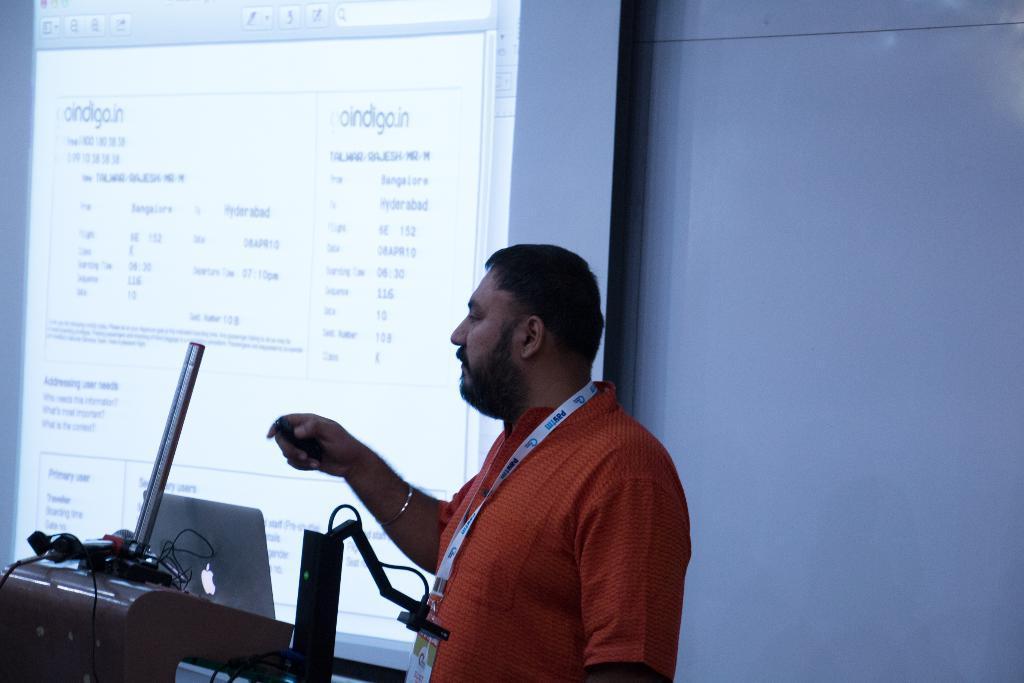Please provide a concise description of this image. In this image we can see a person wearing id card is holding a device in his hand. To the left side of the image we can see a podium on which a laptop and a microphone are placed. In the background, we can see a screen with some text on it. 